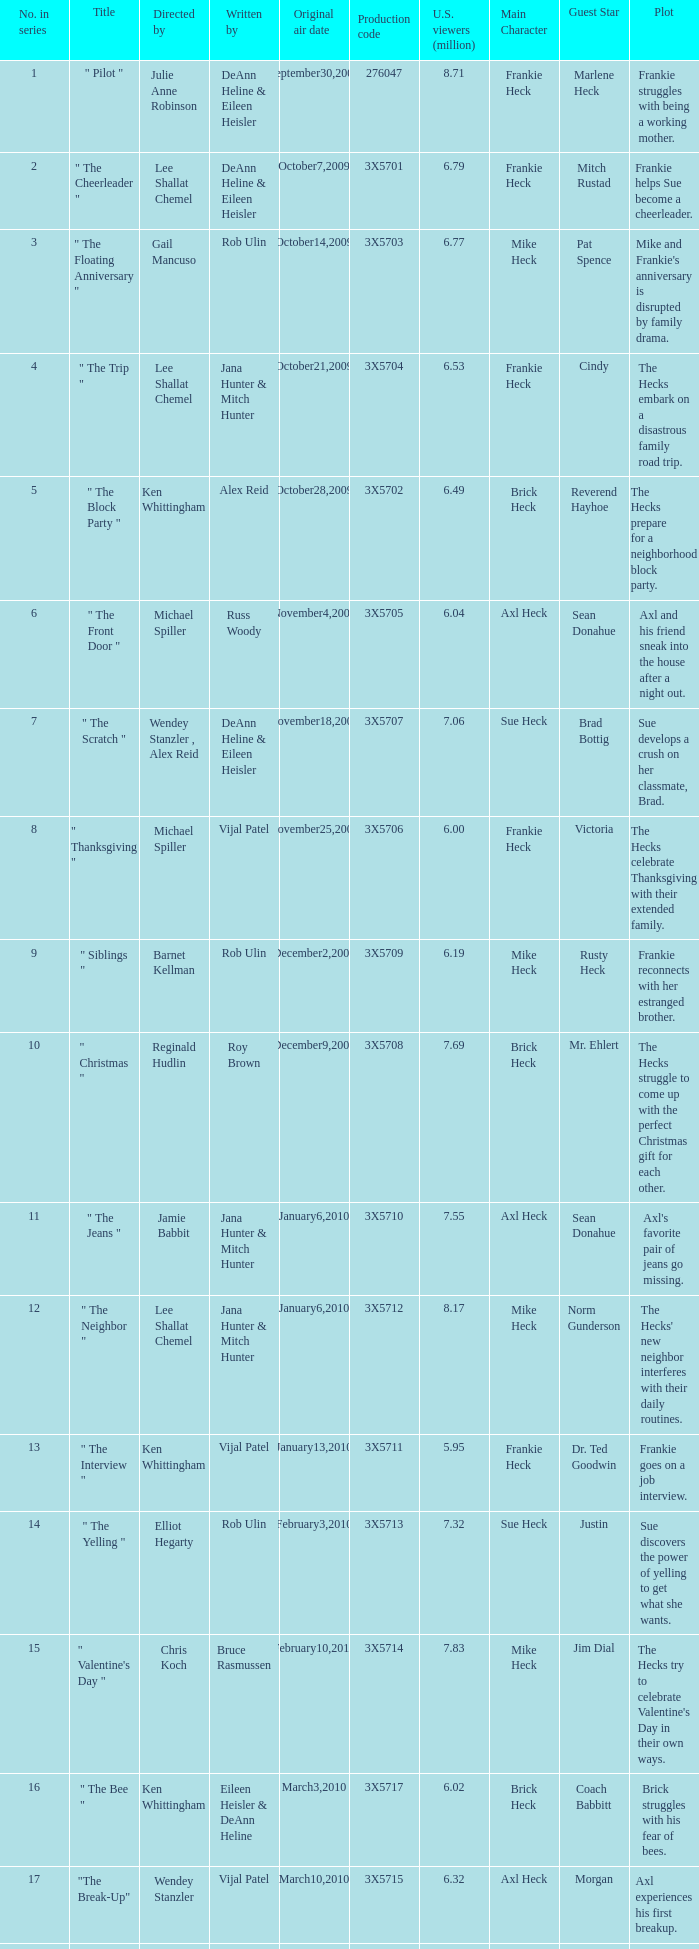What is the episode title that alex reid directed? "The Final Four". 